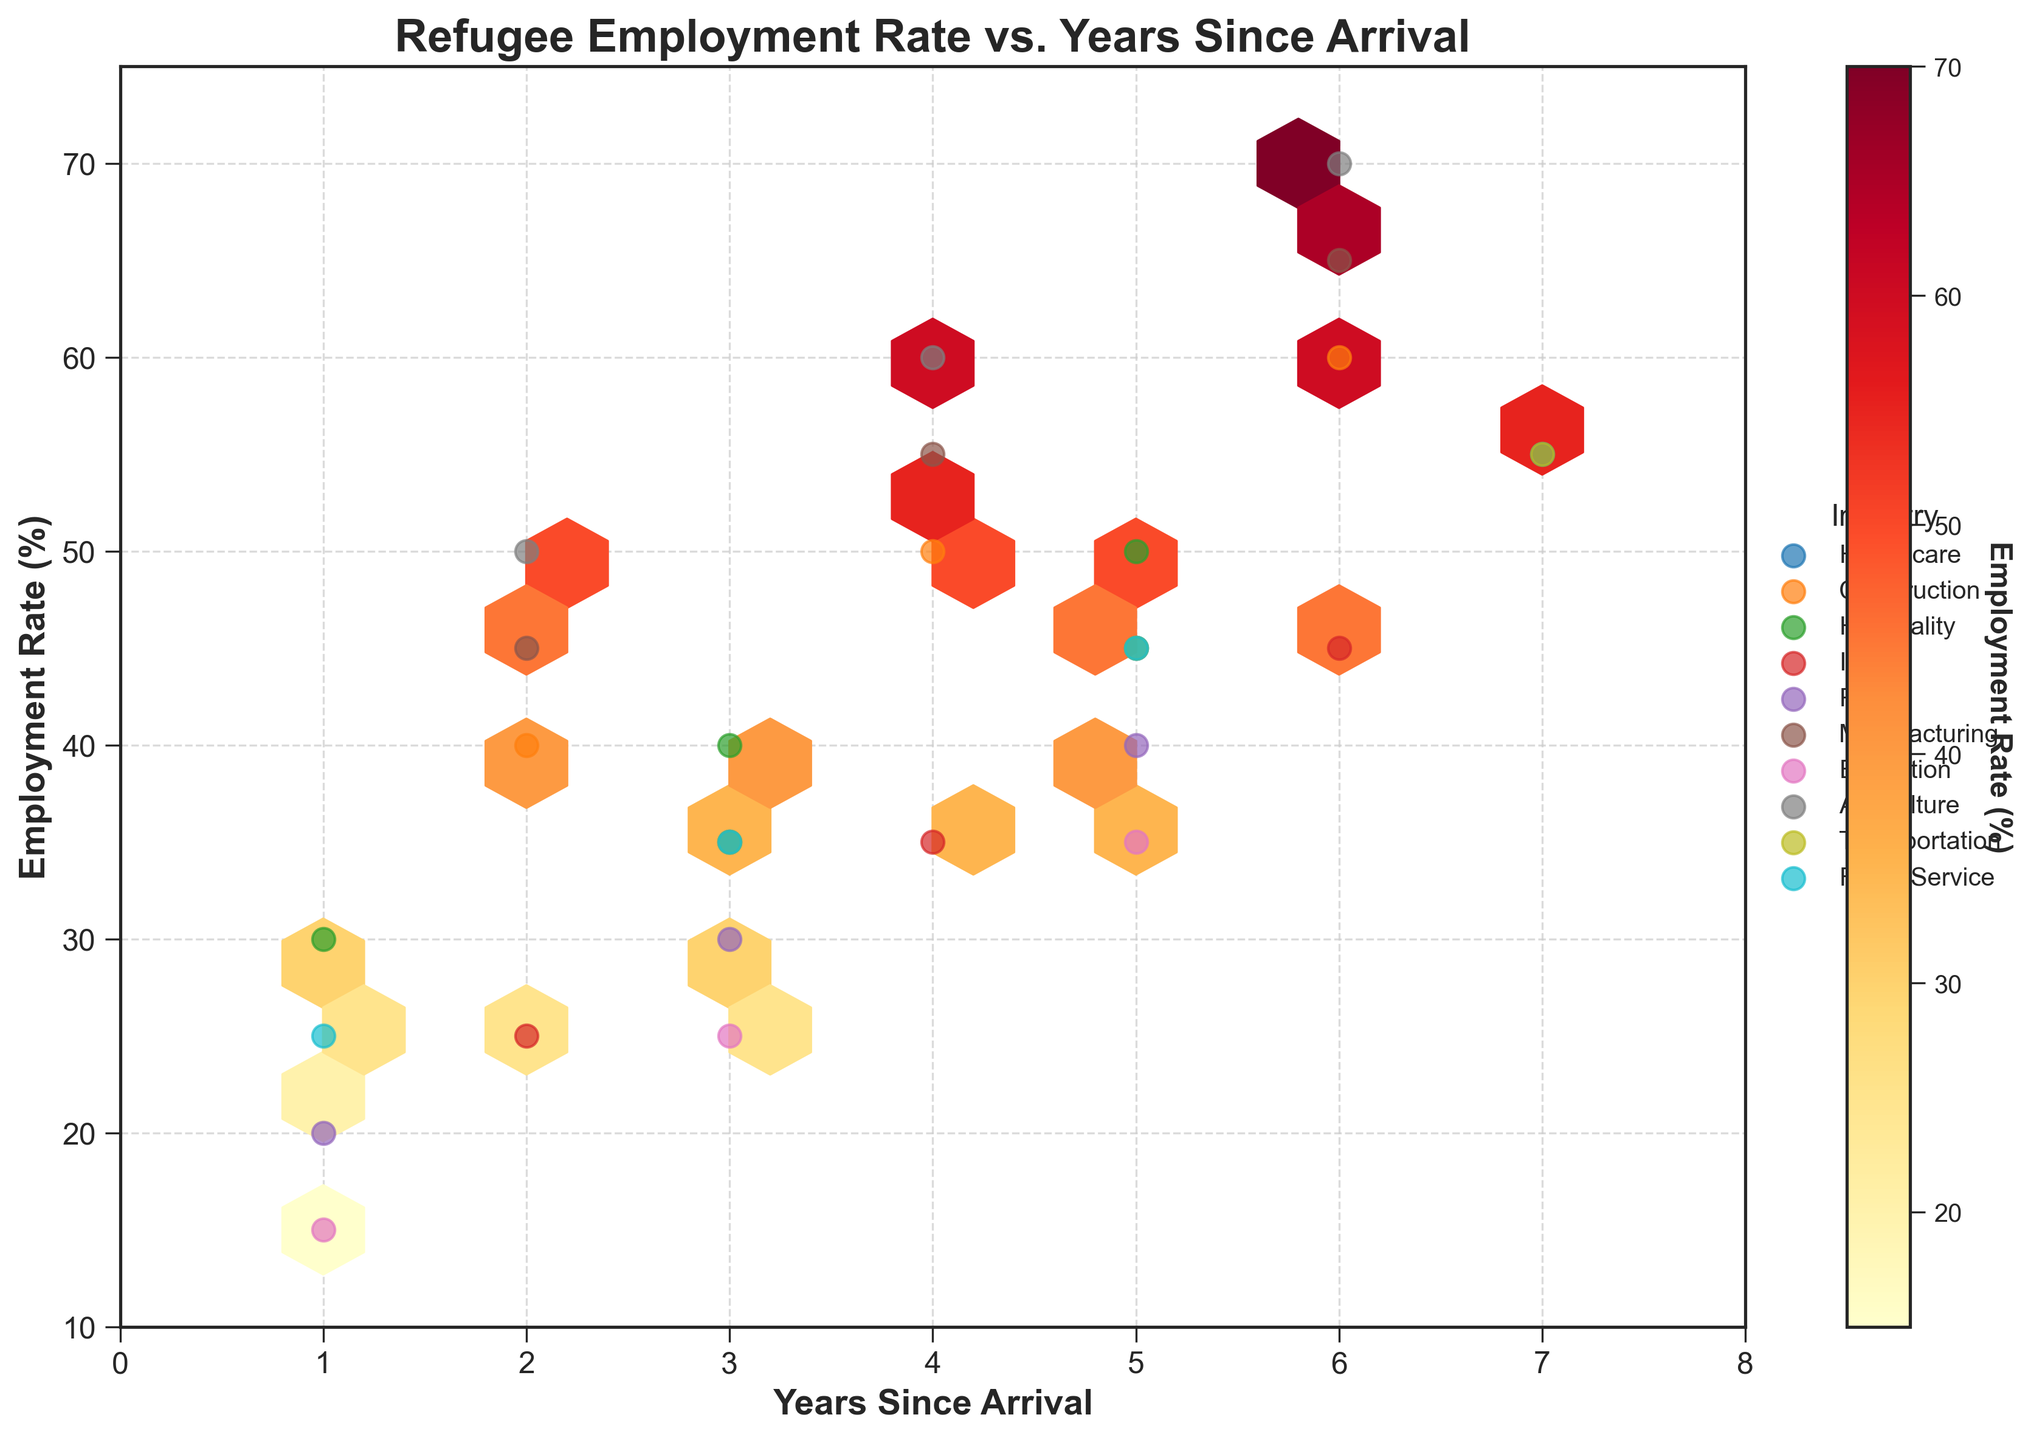What is the title of the plot? The title is displayed prominently at the top of the plot. It is typically one of the first text elements viewers notice.
Answer: "Refugee Employment Rate vs. Years Since Arrival" Which industry appears to have the highest employment rate for 5 years since arrival? To find this, observe the scatter points for each industry at the "5 Years Since Arrival" mark. The one with the highest value on the y-axis at this x-coordinate indicates the highest employment rate.
Answer: "Agriculture" How does the employment rate trend over time for the Healthcare industry? Observe the scatter points for the Healthcare industry. Over the years since arrival (x-axis), note whether the points generally go up, down, or stay the same.
Answer: Increases What is the employment rate for refugees in the IT industry after 6 years since arrival? Locate the scatter point that corresponds to "6 Years Since Arrival" on the x-axis for the IT industry. Read off the employment rate on the y-axis.
Answer: 45% Among the industries present, which one has the lowest employment rate at 1 year since arrival? Locate the scatter points for "1 Year Since Arrival" and compare their y-axis values. The lowest point indicates the lowest employment rate.
Answer: "Education" What is the average employment rate across all industries after 4 years since arrival? Sum the employment rates of all industries at "4 Years Since Arrival" and divide by the number of industries. Refer to each scatter point at the 4-year mark for this calculation.
Answer: (45+50+40+35+30+55+60+45) / 8 = 45.625% In terms of employment rates, how does the Transportation industry compare to the Food Service industry after 5 years since arrival? Find the points for Transportation and Food Service at "5 Years Since Arrival." Compare their y-axis values directly.
Answer: Transportation: 45%, Food Service: 45%, so they are equal Which industry shows the most significant improvement in employment rate from the 2-year to the 6-year mark? Calculate the difference in employment rates at "2 Years Since Arrival" and "6 Years Since Arrival" for each industry. The industry with the highest positive change is the answer.
Answer: Agriculture (70 - 50 = 20%) How does the color intensity of the hexagons change as the employment rate increases? In a hexbin plot, the hexagon color intensity typically represents the density or count of observations. Examine the color gradient from light to dark.
Answer: The color intensity increases (becomes darker) as employment rates increase 